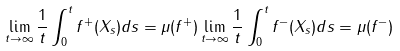<formula> <loc_0><loc_0><loc_500><loc_500>\lim _ { t \to \infty } \frac { 1 } { t } \int _ { 0 } ^ { t } f ^ { + } ( X _ { s } ) d s = \mu ( f ^ { + } ) \lim _ { t \to \infty } \frac { 1 } { t } \int _ { 0 } ^ { t } f ^ { - } ( X _ { s } ) d s = \mu ( f ^ { - } )</formula> 